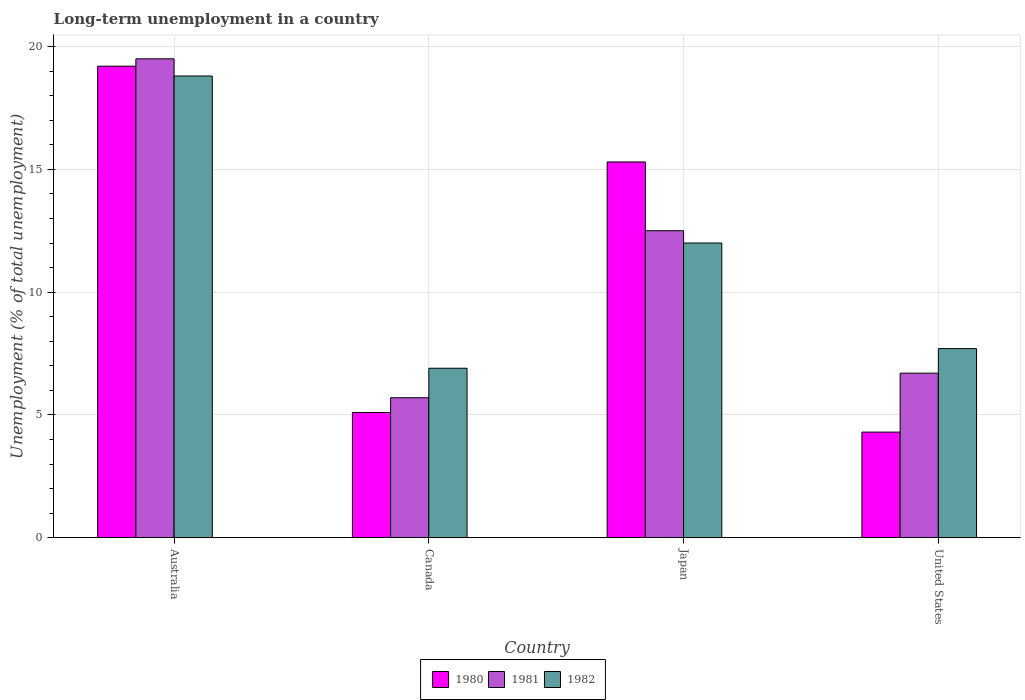How many different coloured bars are there?
Keep it short and to the point. 3. How many groups of bars are there?
Give a very brief answer. 4. How many bars are there on the 3rd tick from the left?
Make the answer very short. 3. What is the label of the 2nd group of bars from the left?
Your answer should be compact. Canada. In how many cases, is the number of bars for a given country not equal to the number of legend labels?
Provide a short and direct response. 0. What is the percentage of long-term unemployed population in 1981 in United States?
Provide a succinct answer. 6.7. Across all countries, what is the maximum percentage of long-term unemployed population in 1982?
Offer a very short reply. 18.8. Across all countries, what is the minimum percentage of long-term unemployed population in 1980?
Keep it short and to the point. 4.3. In which country was the percentage of long-term unemployed population in 1982 maximum?
Your answer should be compact. Australia. What is the total percentage of long-term unemployed population in 1982 in the graph?
Your answer should be very brief. 45.4. What is the difference between the percentage of long-term unemployed population in 1980 in Japan and that in United States?
Keep it short and to the point. 11. What is the difference between the percentage of long-term unemployed population in 1982 in Japan and the percentage of long-term unemployed population in 1980 in Australia?
Make the answer very short. -7.2. What is the average percentage of long-term unemployed population in 1980 per country?
Ensure brevity in your answer.  10.98. What is the difference between the percentage of long-term unemployed population of/in 1980 and percentage of long-term unemployed population of/in 1981 in Australia?
Your answer should be compact. -0.3. What is the ratio of the percentage of long-term unemployed population in 1982 in Canada to that in Japan?
Offer a very short reply. 0.58. What is the difference between the highest and the second highest percentage of long-term unemployed population in 1981?
Provide a short and direct response. 7. What is the difference between the highest and the lowest percentage of long-term unemployed population in 1980?
Offer a terse response. 14.9. What does the 1st bar from the left in Australia represents?
Provide a succinct answer. 1980. What does the 3rd bar from the right in Japan represents?
Offer a terse response. 1980. Are all the bars in the graph horizontal?
Offer a very short reply. No. How many countries are there in the graph?
Give a very brief answer. 4. What is the difference between two consecutive major ticks on the Y-axis?
Provide a succinct answer. 5. Does the graph contain any zero values?
Provide a short and direct response. No. Does the graph contain grids?
Your response must be concise. Yes. How many legend labels are there?
Offer a very short reply. 3. How are the legend labels stacked?
Offer a very short reply. Horizontal. What is the title of the graph?
Ensure brevity in your answer.  Long-term unemployment in a country. Does "1981" appear as one of the legend labels in the graph?
Make the answer very short. Yes. What is the label or title of the X-axis?
Your answer should be very brief. Country. What is the label or title of the Y-axis?
Ensure brevity in your answer.  Unemployment (% of total unemployment). What is the Unemployment (% of total unemployment) of 1980 in Australia?
Make the answer very short. 19.2. What is the Unemployment (% of total unemployment) of 1982 in Australia?
Your answer should be compact. 18.8. What is the Unemployment (% of total unemployment) of 1980 in Canada?
Offer a terse response. 5.1. What is the Unemployment (% of total unemployment) of 1981 in Canada?
Ensure brevity in your answer.  5.7. What is the Unemployment (% of total unemployment) in 1982 in Canada?
Provide a short and direct response. 6.9. What is the Unemployment (% of total unemployment) of 1980 in Japan?
Make the answer very short. 15.3. What is the Unemployment (% of total unemployment) of 1982 in Japan?
Keep it short and to the point. 12. What is the Unemployment (% of total unemployment) in 1980 in United States?
Your answer should be compact. 4.3. What is the Unemployment (% of total unemployment) of 1981 in United States?
Your response must be concise. 6.7. What is the Unemployment (% of total unemployment) in 1982 in United States?
Give a very brief answer. 7.7. Across all countries, what is the maximum Unemployment (% of total unemployment) of 1980?
Your answer should be very brief. 19.2. Across all countries, what is the maximum Unemployment (% of total unemployment) of 1981?
Provide a short and direct response. 19.5. Across all countries, what is the maximum Unemployment (% of total unemployment) in 1982?
Your response must be concise. 18.8. Across all countries, what is the minimum Unemployment (% of total unemployment) of 1980?
Your answer should be compact. 4.3. Across all countries, what is the minimum Unemployment (% of total unemployment) in 1981?
Offer a terse response. 5.7. Across all countries, what is the minimum Unemployment (% of total unemployment) of 1982?
Your response must be concise. 6.9. What is the total Unemployment (% of total unemployment) in 1980 in the graph?
Provide a succinct answer. 43.9. What is the total Unemployment (% of total unemployment) of 1981 in the graph?
Provide a short and direct response. 44.4. What is the total Unemployment (% of total unemployment) in 1982 in the graph?
Offer a very short reply. 45.4. What is the difference between the Unemployment (% of total unemployment) in 1980 in Australia and that in Canada?
Your answer should be very brief. 14.1. What is the difference between the Unemployment (% of total unemployment) of 1980 in Australia and that in Japan?
Ensure brevity in your answer.  3.9. What is the difference between the Unemployment (% of total unemployment) of 1982 in Australia and that in Japan?
Keep it short and to the point. 6.8. What is the difference between the Unemployment (% of total unemployment) in 1980 in Australia and that in United States?
Your answer should be compact. 14.9. What is the difference between the Unemployment (% of total unemployment) of 1980 in Canada and that in Japan?
Ensure brevity in your answer.  -10.2. What is the difference between the Unemployment (% of total unemployment) in 1982 in Canada and that in Japan?
Your response must be concise. -5.1. What is the difference between the Unemployment (% of total unemployment) in 1981 in Canada and that in United States?
Ensure brevity in your answer.  -1. What is the difference between the Unemployment (% of total unemployment) in 1982 in Japan and that in United States?
Your answer should be very brief. 4.3. What is the difference between the Unemployment (% of total unemployment) of 1980 in Australia and the Unemployment (% of total unemployment) of 1982 in Canada?
Ensure brevity in your answer.  12.3. What is the difference between the Unemployment (% of total unemployment) in 1980 in Australia and the Unemployment (% of total unemployment) in 1982 in Japan?
Give a very brief answer. 7.2. What is the difference between the Unemployment (% of total unemployment) of 1981 in Australia and the Unemployment (% of total unemployment) of 1982 in Japan?
Your answer should be very brief. 7.5. What is the difference between the Unemployment (% of total unemployment) of 1980 in Australia and the Unemployment (% of total unemployment) of 1981 in United States?
Ensure brevity in your answer.  12.5. What is the difference between the Unemployment (% of total unemployment) in 1980 in Australia and the Unemployment (% of total unemployment) in 1982 in United States?
Keep it short and to the point. 11.5. What is the difference between the Unemployment (% of total unemployment) of 1981 in Canada and the Unemployment (% of total unemployment) of 1982 in Japan?
Provide a short and direct response. -6.3. What is the difference between the Unemployment (% of total unemployment) in 1980 in Canada and the Unemployment (% of total unemployment) in 1981 in United States?
Provide a short and direct response. -1.6. What is the difference between the Unemployment (% of total unemployment) in 1980 in Canada and the Unemployment (% of total unemployment) in 1982 in United States?
Give a very brief answer. -2.6. What is the difference between the Unemployment (% of total unemployment) in 1981 in Canada and the Unemployment (% of total unemployment) in 1982 in United States?
Offer a terse response. -2. What is the difference between the Unemployment (% of total unemployment) in 1980 in Japan and the Unemployment (% of total unemployment) in 1982 in United States?
Give a very brief answer. 7.6. What is the average Unemployment (% of total unemployment) of 1980 per country?
Keep it short and to the point. 10.97. What is the average Unemployment (% of total unemployment) of 1981 per country?
Provide a succinct answer. 11.1. What is the average Unemployment (% of total unemployment) of 1982 per country?
Offer a terse response. 11.35. What is the difference between the Unemployment (% of total unemployment) in 1980 and Unemployment (% of total unemployment) in 1981 in Australia?
Keep it short and to the point. -0.3. What is the difference between the Unemployment (% of total unemployment) in 1981 and Unemployment (% of total unemployment) in 1982 in Australia?
Offer a very short reply. 0.7. What is the difference between the Unemployment (% of total unemployment) in 1980 and Unemployment (% of total unemployment) in 1981 in Canada?
Offer a terse response. -0.6. What is the difference between the Unemployment (% of total unemployment) in 1980 and Unemployment (% of total unemployment) in 1982 in Canada?
Offer a very short reply. -1.8. What is the difference between the Unemployment (% of total unemployment) of 1980 and Unemployment (% of total unemployment) of 1982 in Japan?
Ensure brevity in your answer.  3.3. What is the difference between the Unemployment (% of total unemployment) of 1981 and Unemployment (% of total unemployment) of 1982 in Japan?
Keep it short and to the point. 0.5. What is the difference between the Unemployment (% of total unemployment) of 1981 and Unemployment (% of total unemployment) of 1982 in United States?
Provide a succinct answer. -1. What is the ratio of the Unemployment (% of total unemployment) in 1980 in Australia to that in Canada?
Your answer should be very brief. 3.76. What is the ratio of the Unemployment (% of total unemployment) in 1981 in Australia to that in Canada?
Your answer should be compact. 3.42. What is the ratio of the Unemployment (% of total unemployment) of 1982 in Australia to that in Canada?
Offer a terse response. 2.72. What is the ratio of the Unemployment (% of total unemployment) in 1980 in Australia to that in Japan?
Make the answer very short. 1.25. What is the ratio of the Unemployment (% of total unemployment) in 1981 in Australia to that in Japan?
Your answer should be compact. 1.56. What is the ratio of the Unemployment (% of total unemployment) in 1982 in Australia to that in Japan?
Make the answer very short. 1.57. What is the ratio of the Unemployment (% of total unemployment) of 1980 in Australia to that in United States?
Your answer should be compact. 4.47. What is the ratio of the Unemployment (% of total unemployment) of 1981 in Australia to that in United States?
Make the answer very short. 2.91. What is the ratio of the Unemployment (% of total unemployment) of 1982 in Australia to that in United States?
Provide a succinct answer. 2.44. What is the ratio of the Unemployment (% of total unemployment) of 1980 in Canada to that in Japan?
Offer a very short reply. 0.33. What is the ratio of the Unemployment (% of total unemployment) of 1981 in Canada to that in Japan?
Your answer should be very brief. 0.46. What is the ratio of the Unemployment (% of total unemployment) of 1982 in Canada to that in Japan?
Your answer should be very brief. 0.57. What is the ratio of the Unemployment (% of total unemployment) of 1980 in Canada to that in United States?
Your answer should be compact. 1.19. What is the ratio of the Unemployment (% of total unemployment) of 1981 in Canada to that in United States?
Give a very brief answer. 0.85. What is the ratio of the Unemployment (% of total unemployment) in 1982 in Canada to that in United States?
Provide a short and direct response. 0.9. What is the ratio of the Unemployment (% of total unemployment) in 1980 in Japan to that in United States?
Provide a short and direct response. 3.56. What is the ratio of the Unemployment (% of total unemployment) in 1981 in Japan to that in United States?
Give a very brief answer. 1.87. What is the ratio of the Unemployment (% of total unemployment) in 1982 in Japan to that in United States?
Make the answer very short. 1.56. What is the difference between the highest and the lowest Unemployment (% of total unemployment) in 1980?
Make the answer very short. 14.9. 